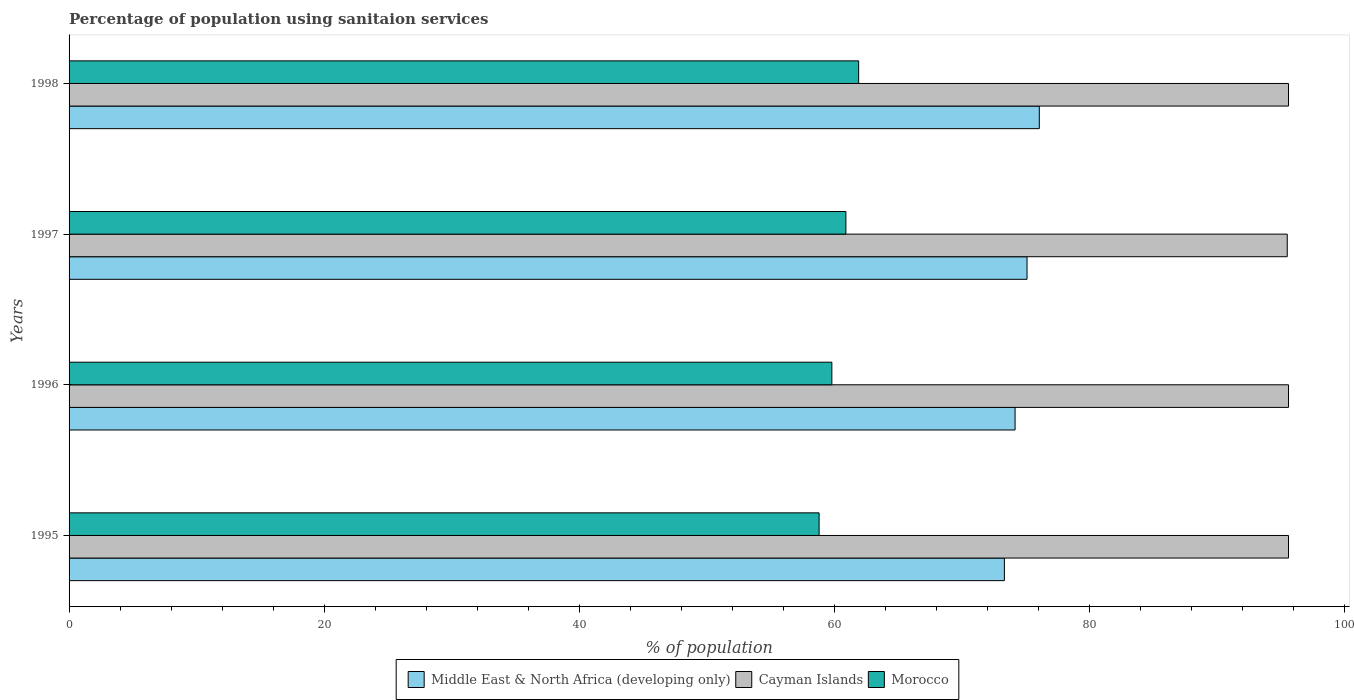How many different coloured bars are there?
Your response must be concise. 3. How many groups of bars are there?
Offer a terse response. 4. Are the number of bars on each tick of the Y-axis equal?
Your response must be concise. Yes. How many bars are there on the 2nd tick from the top?
Your answer should be very brief. 3. What is the label of the 1st group of bars from the top?
Your response must be concise. 1998. What is the percentage of population using sanitaion services in Middle East & North Africa (developing only) in 1997?
Your response must be concise. 75.1. Across all years, what is the maximum percentage of population using sanitaion services in Cayman Islands?
Offer a very short reply. 95.6. Across all years, what is the minimum percentage of population using sanitaion services in Middle East & North Africa (developing only)?
Provide a short and direct response. 73.33. In which year was the percentage of population using sanitaion services in Middle East & North Africa (developing only) maximum?
Provide a succinct answer. 1998. In which year was the percentage of population using sanitaion services in Morocco minimum?
Provide a succinct answer. 1995. What is the total percentage of population using sanitaion services in Morocco in the graph?
Ensure brevity in your answer.  241.4. What is the difference between the percentage of population using sanitaion services in Middle East & North Africa (developing only) in 1996 and that in 1997?
Make the answer very short. -0.94. What is the difference between the percentage of population using sanitaion services in Middle East & North Africa (developing only) in 1997 and the percentage of population using sanitaion services in Cayman Islands in 1995?
Provide a succinct answer. -20.5. What is the average percentage of population using sanitaion services in Middle East & North Africa (developing only) per year?
Offer a very short reply. 74.66. In the year 1998, what is the difference between the percentage of population using sanitaion services in Cayman Islands and percentage of population using sanitaion services in Middle East & North Africa (developing only)?
Give a very brief answer. 19.54. What is the ratio of the percentage of population using sanitaion services in Morocco in 1995 to that in 1998?
Your answer should be very brief. 0.95. Is the difference between the percentage of population using sanitaion services in Cayman Islands in 1997 and 1998 greater than the difference between the percentage of population using sanitaion services in Middle East & North Africa (developing only) in 1997 and 1998?
Offer a terse response. Yes. What is the difference between the highest and the second highest percentage of population using sanitaion services in Morocco?
Your response must be concise. 1. What is the difference between the highest and the lowest percentage of population using sanitaion services in Morocco?
Offer a terse response. 3.1. Is the sum of the percentage of population using sanitaion services in Cayman Islands in 1995 and 1998 greater than the maximum percentage of population using sanitaion services in Morocco across all years?
Your response must be concise. Yes. What does the 3rd bar from the top in 1997 represents?
Ensure brevity in your answer.  Middle East & North Africa (developing only). What does the 2nd bar from the bottom in 1996 represents?
Give a very brief answer. Cayman Islands. How many bars are there?
Your answer should be compact. 12. Are all the bars in the graph horizontal?
Keep it short and to the point. Yes. What is the difference between two consecutive major ticks on the X-axis?
Your answer should be compact. 20. Does the graph contain any zero values?
Give a very brief answer. No. Where does the legend appear in the graph?
Offer a terse response. Bottom center. How are the legend labels stacked?
Provide a succinct answer. Horizontal. What is the title of the graph?
Give a very brief answer. Percentage of population using sanitaion services. Does "Low income" appear as one of the legend labels in the graph?
Your response must be concise. No. What is the label or title of the X-axis?
Provide a succinct answer. % of population. What is the label or title of the Y-axis?
Provide a succinct answer. Years. What is the % of population of Middle East & North Africa (developing only) in 1995?
Offer a terse response. 73.33. What is the % of population of Cayman Islands in 1995?
Provide a short and direct response. 95.6. What is the % of population of Morocco in 1995?
Offer a very short reply. 58.8. What is the % of population of Middle East & North Africa (developing only) in 1996?
Make the answer very short. 74.16. What is the % of population of Cayman Islands in 1996?
Offer a terse response. 95.6. What is the % of population in Morocco in 1996?
Your answer should be compact. 59.8. What is the % of population in Middle East & North Africa (developing only) in 1997?
Your response must be concise. 75.1. What is the % of population in Cayman Islands in 1997?
Ensure brevity in your answer.  95.5. What is the % of population of Morocco in 1997?
Ensure brevity in your answer.  60.9. What is the % of population of Middle East & North Africa (developing only) in 1998?
Keep it short and to the point. 76.06. What is the % of population of Cayman Islands in 1998?
Give a very brief answer. 95.6. What is the % of population in Morocco in 1998?
Ensure brevity in your answer.  61.9. Across all years, what is the maximum % of population in Middle East & North Africa (developing only)?
Provide a succinct answer. 76.06. Across all years, what is the maximum % of population in Cayman Islands?
Give a very brief answer. 95.6. Across all years, what is the maximum % of population of Morocco?
Make the answer very short. 61.9. Across all years, what is the minimum % of population in Middle East & North Africa (developing only)?
Your answer should be compact. 73.33. Across all years, what is the minimum % of population of Cayman Islands?
Your answer should be very brief. 95.5. Across all years, what is the minimum % of population in Morocco?
Ensure brevity in your answer.  58.8. What is the total % of population of Middle East & North Africa (developing only) in the graph?
Provide a short and direct response. 298.65. What is the total % of population of Cayman Islands in the graph?
Offer a terse response. 382.3. What is the total % of population in Morocco in the graph?
Provide a short and direct response. 241.4. What is the difference between the % of population in Middle East & North Africa (developing only) in 1995 and that in 1996?
Offer a very short reply. -0.84. What is the difference between the % of population in Middle East & North Africa (developing only) in 1995 and that in 1997?
Keep it short and to the point. -1.78. What is the difference between the % of population in Morocco in 1995 and that in 1997?
Your response must be concise. -2.1. What is the difference between the % of population in Middle East & North Africa (developing only) in 1995 and that in 1998?
Provide a short and direct response. -2.74. What is the difference between the % of population of Morocco in 1995 and that in 1998?
Provide a short and direct response. -3.1. What is the difference between the % of population in Middle East & North Africa (developing only) in 1996 and that in 1997?
Your response must be concise. -0.94. What is the difference between the % of population in Cayman Islands in 1996 and that in 1997?
Give a very brief answer. 0.1. What is the difference between the % of population in Morocco in 1996 and that in 1997?
Offer a very short reply. -1.1. What is the difference between the % of population of Middle East & North Africa (developing only) in 1996 and that in 1998?
Make the answer very short. -1.9. What is the difference between the % of population of Cayman Islands in 1996 and that in 1998?
Offer a very short reply. 0. What is the difference between the % of population of Middle East & North Africa (developing only) in 1997 and that in 1998?
Your response must be concise. -0.96. What is the difference between the % of population in Cayman Islands in 1997 and that in 1998?
Offer a terse response. -0.1. What is the difference between the % of population in Middle East & North Africa (developing only) in 1995 and the % of population in Cayman Islands in 1996?
Provide a short and direct response. -22.27. What is the difference between the % of population in Middle East & North Africa (developing only) in 1995 and the % of population in Morocco in 1996?
Offer a terse response. 13.53. What is the difference between the % of population of Cayman Islands in 1995 and the % of population of Morocco in 1996?
Ensure brevity in your answer.  35.8. What is the difference between the % of population of Middle East & North Africa (developing only) in 1995 and the % of population of Cayman Islands in 1997?
Ensure brevity in your answer.  -22.17. What is the difference between the % of population of Middle East & North Africa (developing only) in 1995 and the % of population of Morocco in 1997?
Give a very brief answer. 12.43. What is the difference between the % of population in Cayman Islands in 1995 and the % of population in Morocco in 1997?
Keep it short and to the point. 34.7. What is the difference between the % of population of Middle East & North Africa (developing only) in 1995 and the % of population of Cayman Islands in 1998?
Your answer should be very brief. -22.27. What is the difference between the % of population of Middle East & North Africa (developing only) in 1995 and the % of population of Morocco in 1998?
Provide a short and direct response. 11.43. What is the difference between the % of population in Cayman Islands in 1995 and the % of population in Morocco in 1998?
Give a very brief answer. 33.7. What is the difference between the % of population of Middle East & North Africa (developing only) in 1996 and the % of population of Cayman Islands in 1997?
Provide a short and direct response. -21.34. What is the difference between the % of population of Middle East & North Africa (developing only) in 1996 and the % of population of Morocco in 1997?
Provide a short and direct response. 13.26. What is the difference between the % of population of Cayman Islands in 1996 and the % of population of Morocco in 1997?
Provide a short and direct response. 34.7. What is the difference between the % of population in Middle East & North Africa (developing only) in 1996 and the % of population in Cayman Islands in 1998?
Provide a short and direct response. -21.44. What is the difference between the % of population in Middle East & North Africa (developing only) in 1996 and the % of population in Morocco in 1998?
Offer a terse response. 12.26. What is the difference between the % of population of Cayman Islands in 1996 and the % of population of Morocco in 1998?
Offer a terse response. 33.7. What is the difference between the % of population of Middle East & North Africa (developing only) in 1997 and the % of population of Cayman Islands in 1998?
Provide a succinct answer. -20.5. What is the difference between the % of population in Middle East & North Africa (developing only) in 1997 and the % of population in Morocco in 1998?
Make the answer very short. 13.2. What is the difference between the % of population of Cayman Islands in 1997 and the % of population of Morocco in 1998?
Your answer should be very brief. 33.6. What is the average % of population in Middle East & North Africa (developing only) per year?
Offer a very short reply. 74.66. What is the average % of population in Cayman Islands per year?
Ensure brevity in your answer.  95.58. What is the average % of population of Morocco per year?
Offer a terse response. 60.35. In the year 1995, what is the difference between the % of population in Middle East & North Africa (developing only) and % of population in Cayman Islands?
Ensure brevity in your answer.  -22.27. In the year 1995, what is the difference between the % of population of Middle East & North Africa (developing only) and % of population of Morocco?
Keep it short and to the point. 14.53. In the year 1995, what is the difference between the % of population in Cayman Islands and % of population in Morocco?
Provide a succinct answer. 36.8. In the year 1996, what is the difference between the % of population in Middle East & North Africa (developing only) and % of population in Cayman Islands?
Provide a short and direct response. -21.44. In the year 1996, what is the difference between the % of population of Middle East & North Africa (developing only) and % of population of Morocco?
Provide a short and direct response. 14.36. In the year 1996, what is the difference between the % of population in Cayman Islands and % of population in Morocco?
Your answer should be compact. 35.8. In the year 1997, what is the difference between the % of population of Middle East & North Africa (developing only) and % of population of Cayman Islands?
Provide a succinct answer. -20.4. In the year 1997, what is the difference between the % of population in Middle East & North Africa (developing only) and % of population in Morocco?
Your answer should be compact. 14.2. In the year 1997, what is the difference between the % of population of Cayman Islands and % of population of Morocco?
Your response must be concise. 34.6. In the year 1998, what is the difference between the % of population of Middle East & North Africa (developing only) and % of population of Cayman Islands?
Give a very brief answer. -19.54. In the year 1998, what is the difference between the % of population of Middle East & North Africa (developing only) and % of population of Morocco?
Your answer should be compact. 14.16. In the year 1998, what is the difference between the % of population in Cayman Islands and % of population in Morocco?
Your response must be concise. 33.7. What is the ratio of the % of population of Middle East & North Africa (developing only) in 1995 to that in 1996?
Keep it short and to the point. 0.99. What is the ratio of the % of population in Morocco in 1995 to that in 1996?
Your answer should be very brief. 0.98. What is the ratio of the % of population in Middle East & North Africa (developing only) in 1995 to that in 1997?
Offer a terse response. 0.98. What is the ratio of the % of population of Morocco in 1995 to that in 1997?
Your response must be concise. 0.97. What is the ratio of the % of population of Middle East & North Africa (developing only) in 1995 to that in 1998?
Your answer should be compact. 0.96. What is the ratio of the % of population of Cayman Islands in 1995 to that in 1998?
Your response must be concise. 1. What is the ratio of the % of population in Morocco in 1995 to that in 1998?
Offer a very short reply. 0.95. What is the ratio of the % of population in Middle East & North Africa (developing only) in 1996 to that in 1997?
Provide a succinct answer. 0.99. What is the ratio of the % of population in Cayman Islands in 1996 to that in 1997?
Keep it short and to the point. 1. What is the ratio of the % of population of Morocco in 1996 to that in 1997?
Provide a short and direct response. 0.98. What is the ratio of the % of population in Middle East & North Africa (developing only) in 1996 to that in 1998?
Offer a terse response. 0.97. What is the ratio of the % of population of Morocco in 1996 to that in 1998?
Offer a terse response. 0.97. What is the ratio of the % of population of Middle East & North Africa (developing only) in 1997 to that in 1998?
Your answer should be very brief. 0.99. What is the ratio of the % of population in Morocco in 1997 to that in 1998?
Provide a succinct answer. 0.98. What is the difference between the highest and the second highest % of population of Middle East & North Africa (developing only)?
Give a very brief answer. 0.96. What is the difference between the highest and the second highest % of population in Cayman Islands?
Keep it short and to the point. 0. What is the difference between the highest and the second highest % of population of Morocco?
Make the answer very short. 1. What is the difference between the highest and the lowest % of population in Middle East & North Africa (developing only)?
Your response must be concise. 2.74. 